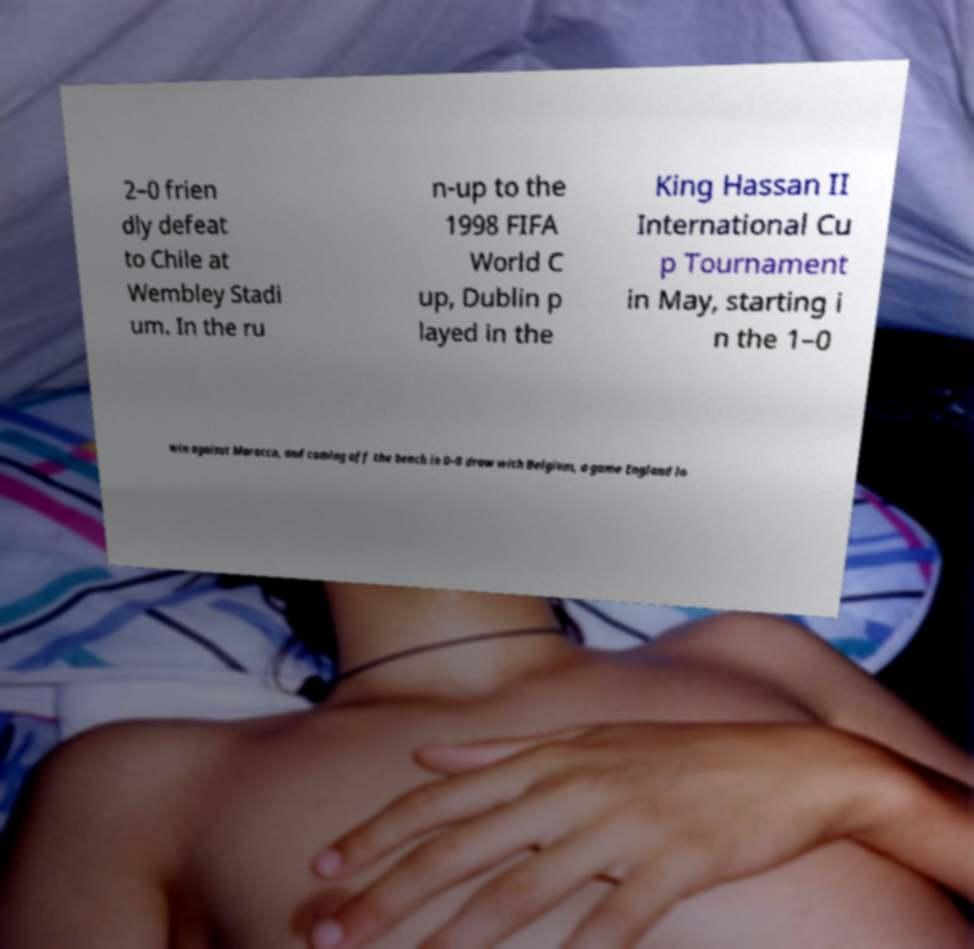Can you accurately transcribe the text from the provided image for me? 2–0 frien dly defeat to Chile at Wembley Stadi um. In the ru n-up to the 1998 FIFA World C up, Dublin p layed in the King Hassan II International Cu p Tournament in May, starting i n the 1–0 win against Morocco, and coming off the bench in 0–0 draw with Belgium, a game England lo 